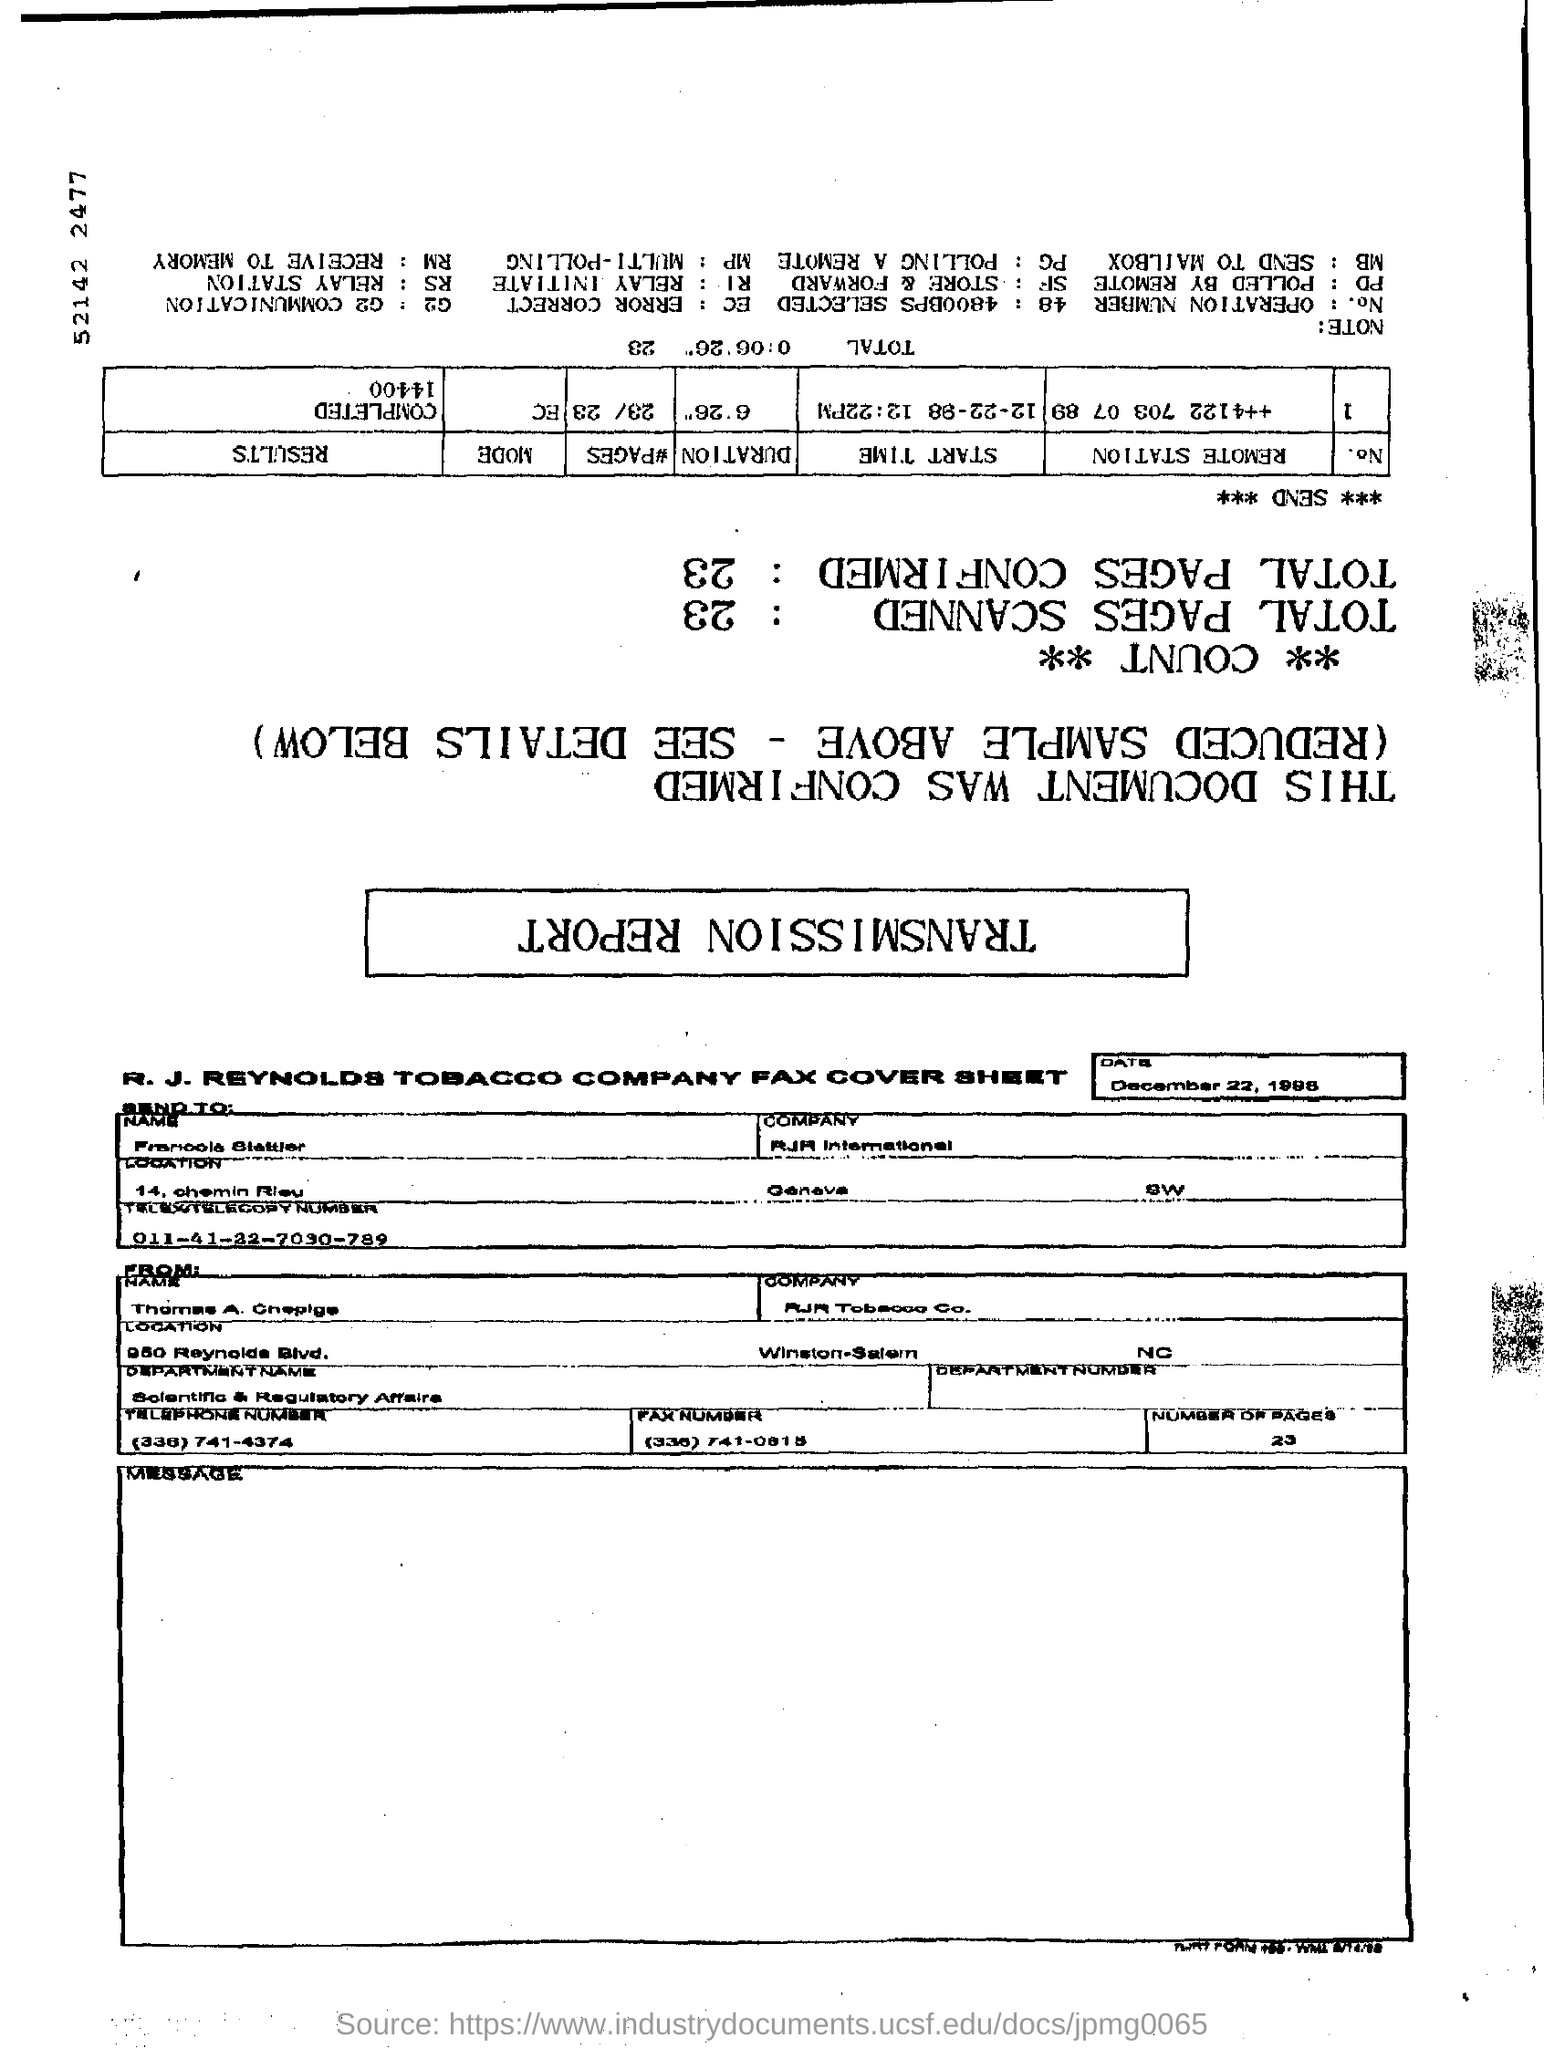What is the Date?
Keep it short and to the point. December 22, 1998. 